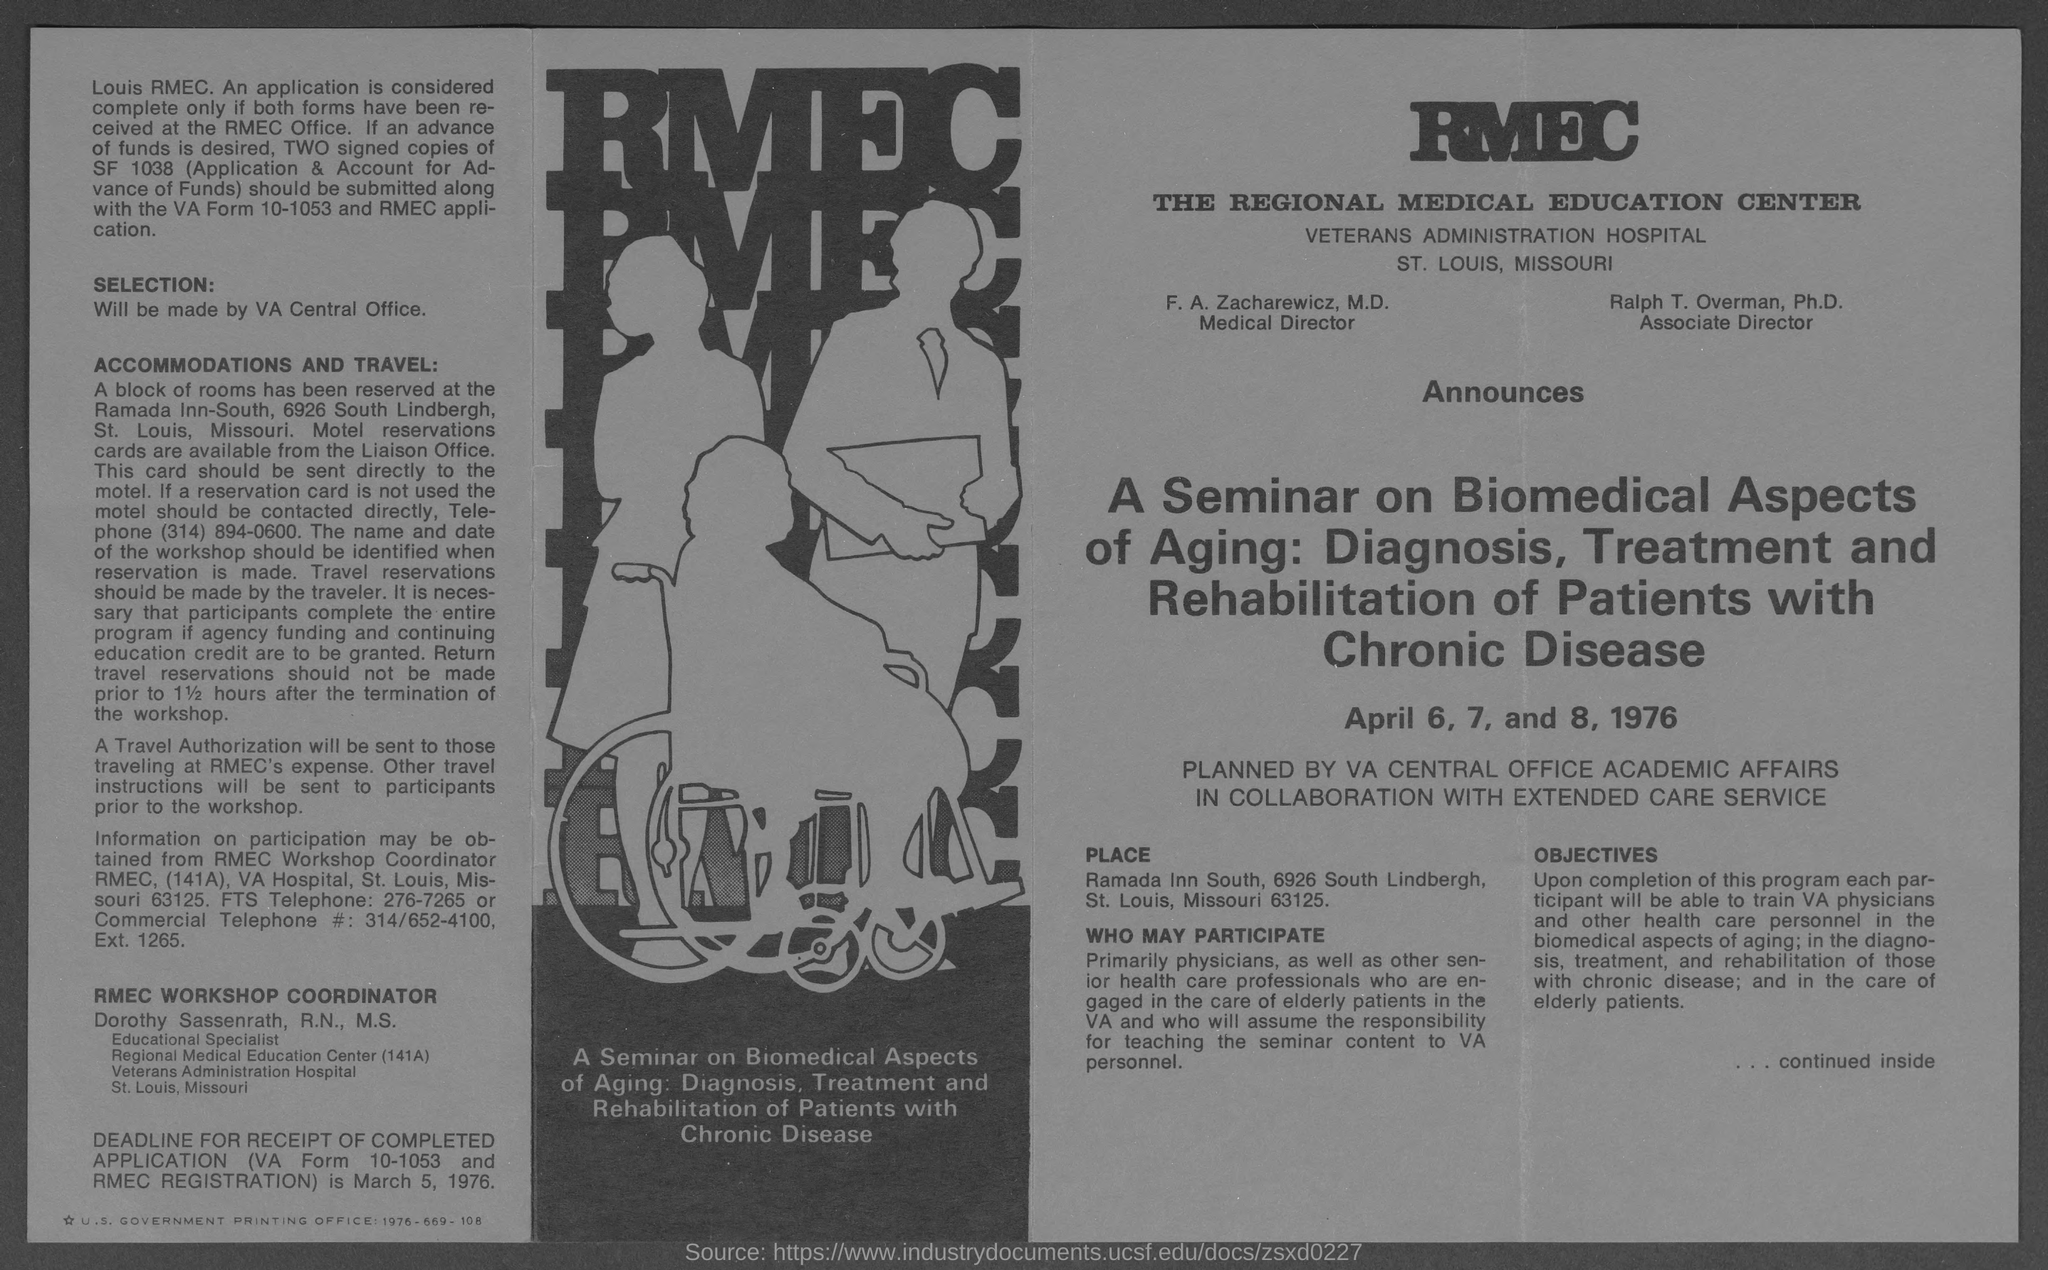Draw attention to some important aspects in this diagram. Dorothy Sassenrath holds the position of Educational Specialist. Ralph T. Overman is the associate director. FA Zacharewicz is the medical director. 